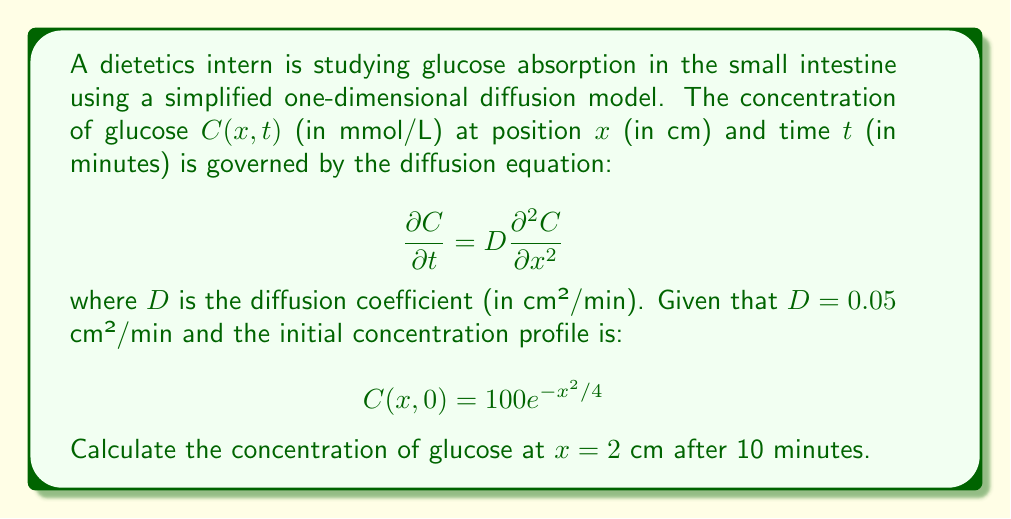What is the answer to this math problem? To solve this problem, we need to use the fundamental solution of the diffusion equation, also known as the heat kernel. For a one-dimensional diffusion problem with an initial condition $C(x,0) = f(x)$, the solution at any time $t > 0$ is given by:

$$C(x,t) = \frac{1}{\sqrt{4\pi Dt}} \int_{-\infty}^{\infty} f(y) e^{-\frac{(x-y)^2}{4Dt}} dy$$

In our case, $f(x) = 100e^{-x^2/4}$. Let's substitute this into the solution:

$$C(x,t) = \frac{100}{\sqrt{4\pi Dt}} \int_{-\infty}^{\infty} e^{-y^2/4} e^{-\frac{(x-y)^2}{4Dt}} dy$$

This integral can be evaluated using the convolution of Gaussian functions. The result is:

$$C(x,t) = \frac{100}{\sqrt{1 + t/0.05}} e^{-\frac{x^2}{4(0.05 + t)}}$$

Now, we can substitute the given values:
$x = 2$ cm
$t = 10$ minutes
$D = 0.05$ cm²/min

$$C(2,10) = \frac{100}{\sqrt{1 + 10/0.05}} e^{-\frac{2^2}{4(0.05 + 10)}}$$

$$= \frac{100}{\sqrt{201}} e^{-\frac{4}{40.2}}$$

$$\approx 7.0457 \text{ mmol/L}$$
Answer: The concentration of glucose at $x = 2$ cm after 10 minutes is approximately 7.05 mmol/L. 